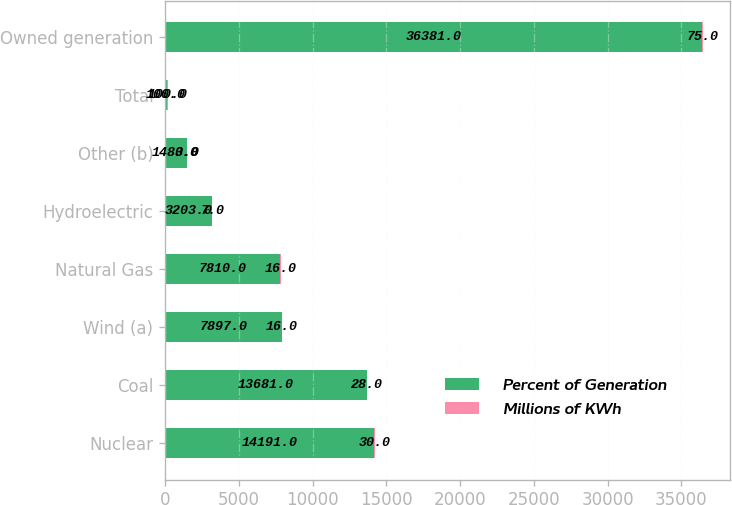Convert chart to OTSL. <chart><loc_0><loc_0><loc_500><loc_500><stacked_bar_chart><ecel><fcel>Nuclear<fcel>Coal<fcel>Wind (a)<fcel>Natural Gas<fcel>Hydroelectric<fcel>Other (b)<fcel>Total<fcel>Owned generation<nl><fcel>Percent of Generation<fcel>14191<fcel>13681<fcel>7897<fcel>7810<fcel>3203<fcel>1480<fcel>100<fcel>36381<nl><fcel>Millions of KWh<fcel>30<fcel>28<fcel>16<fcel>16<fcel>7<fcel>3<fcel>100<fcel>75<nl></chart> 